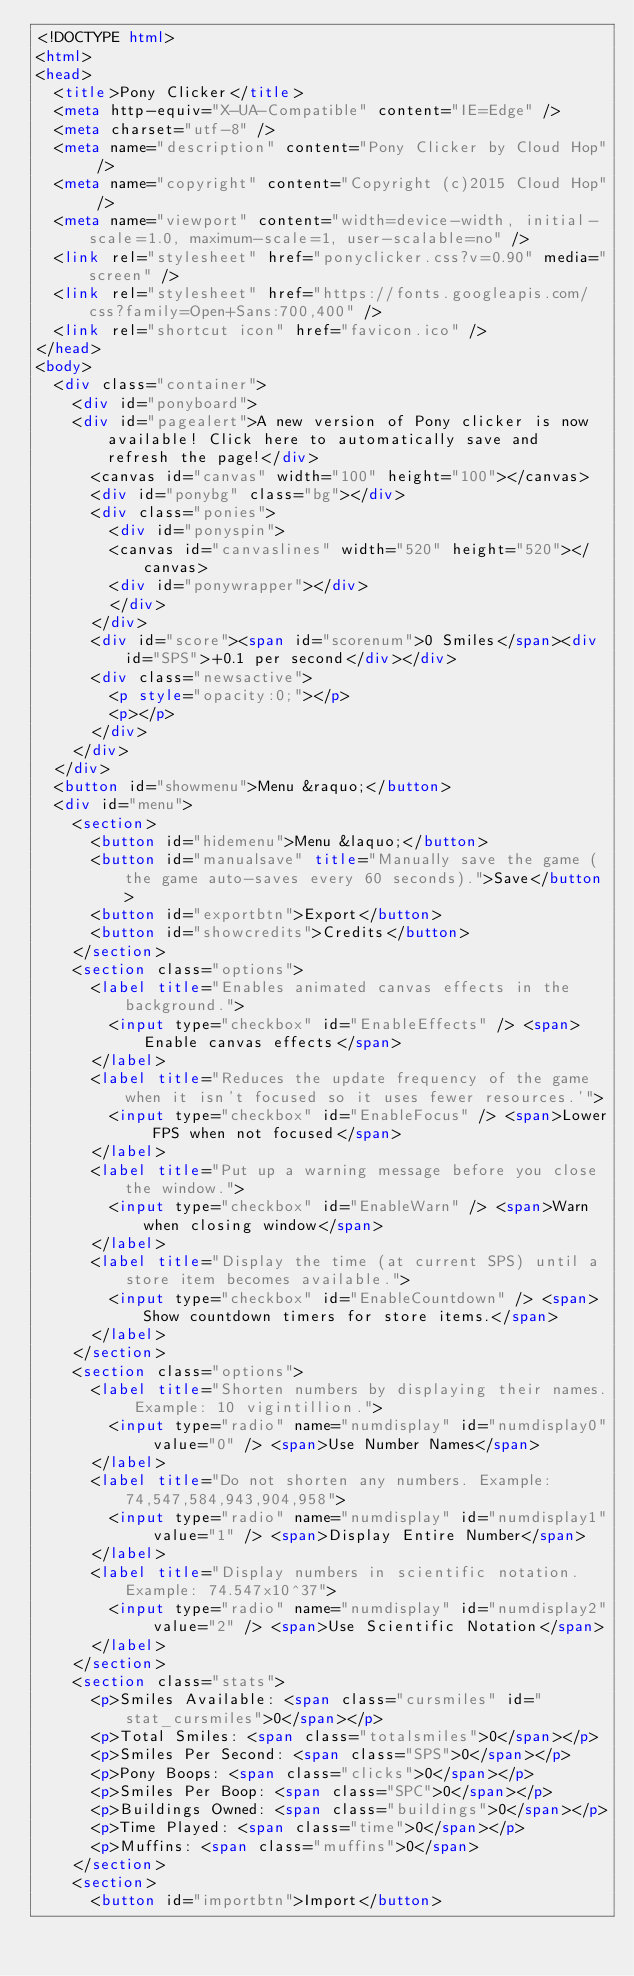Convert code to text. <code><loc_0><loc_0><loc_500><loc_500><_HTML_><!DOCTYPE html>
<html>
<head>
  <title>Pony Clicker</title>
  <meta http-equiv="X-UA-Compatible" content="IE=Edge" />
  <meta charset="utf-8" />
  <meta name="description" content="Pony Clicker by Cloud Hop" />
  <meta name="copyright" content="Copyright (c)2015 Cloud Hop" />
  <meta name="viewport" content="width=device-width, initial-scale=1.0, maximum-scale=1, user-scalable=no" />
  <link rel="stylesheet" href="ponyclicker.css?v=0.90" media="screen" />
  <link rel="stylesheet" href="https://fonts.googleapis.com/css?family=Open+Sans:700,400" />
  <link rel="shortcut icon" href="favicon.ico" />
</head>
<body>
  <div class="container">
    <div id="ponyboard">
    <div id="pagealert">A new version of Pony clicker is now available! Click here to automatically save and refresh the page!</div>
      <canvas id="canvas" width="100" height="100"></canvas>
      <div id="ponybg" class="bg"></div>
      <div class="ponies">
        <div id="ponyspin">
        <canvas id="canvaslines" width="520" height="520"></canvas>
        <div id="ponywrapper"></div>
        </div>
      </div>
      <div id="score"><span id="scorenum">0 Smiles</span><div id="SPS">+0.1 per second</div></div>
      <div class="newsactive">
        <p style="opacity:0;"></p>
        <p></p>
      </div>
    </div>
  </div>
  <button id="showmenu">Menu &raquo;</button>
  <div id="menu">
    <section>
      <button id="hidemenu">Menu &laquo;</button>
      <button id="manualsave" title="Manually save the game (the game auto-saves every 60 seconds).">Save</button>
      <button id="exportbtn">Export</button>
      <button id="showcredits">Credits</button>
    </section>
    <section class="options">
      <label title="Enables animated canvas effects in the background.">
        <input type="checkbox" id="EnableEffects" /> <span>Enable canvas effects</span>
      </label>
      <label title="Reduces the update frequency of the game when it isn't focused so it uses fewer resources.'">
        <input type="checkbox" id="EnableFocus" /> <span>Lower FPS when not focused</span>
      </label>
      <label title="Put up a warning message before you close the window.">
        <input type="checkbox" id="EnableWarn" /> <span>Warn when closing window</span>
      </label>
      <label title="Display the time (at current SPS) until a store item becomes available.">
        <input type="checkbox" id="EnableCountdown" /> <span>Show countdown timers for store items.</span>
      </label>
    </section>
    <section class="options">
      <label title="Shorten numbers by displaying their names. Example: 10 vigintillion.">
        <input type="radio" name="numdisplay" id="numdisplay0" value="0" /> <span>Use Number Names</span>
      </label>
      <label title="Do not shorten any numbers. Example: 74,547,584,943,904,958">
        <input type="radio" name="numdisplay" id="numdisplay1" value="1" /> <span>Display Entire Number</span>
      </label>
      <label title="Display numbers in scientific notation. Example: 74.547x10^37">
        <input type="radio" name="numdisplay" id="numdisplay2" value="2" /> <span>Use Scientific Notation</span>
      </label>
    </section>
    <section class="stats">
      <p>Smiles Available: <span class="cursmiles" id="stat_cursmiles">0</span></p>
      <p>Total Smiles: <span class="totalsmiles">0</span></p>
      <p>Smiles Per Second: <span class="SPS">0</span></p>
      <p>Pony Boops: <span class="clicks">0</span></p>
      <p>Smiles Per Boop: <span class="SPC">0</span></p>
      <p>Buildings Owned: <span class="buildings">0</span></p>
      <p>Time Played: <span class="time">0</span></p>
      <p>Muffins: <span class="muffins">0</span>
    </section>
    <section>
      <button id="importbtn">Import</button></code> 